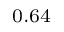<formula> <loc_0><loc_0><loc_500><loc_500>_ { 0 . 6 4 }</formula> 